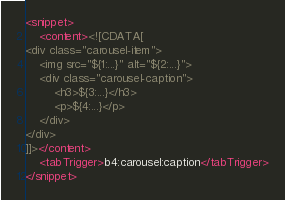<code> <loc_0><loc_0><loc_500><loc_500><_XML_><snippet>
	<content><![CDATA[
<div class="carousel-item">
	<img src="${1:...}" alt="${2:...}">
	<div class="carousel-caption">
		<h3>${3:...}</h3>
		<p>${4:...}</p>
	</div>
</div>
]]></content>
	<tabTrigger>b4:carousel:caption</tabTrigger>
</snippet>
</code> 